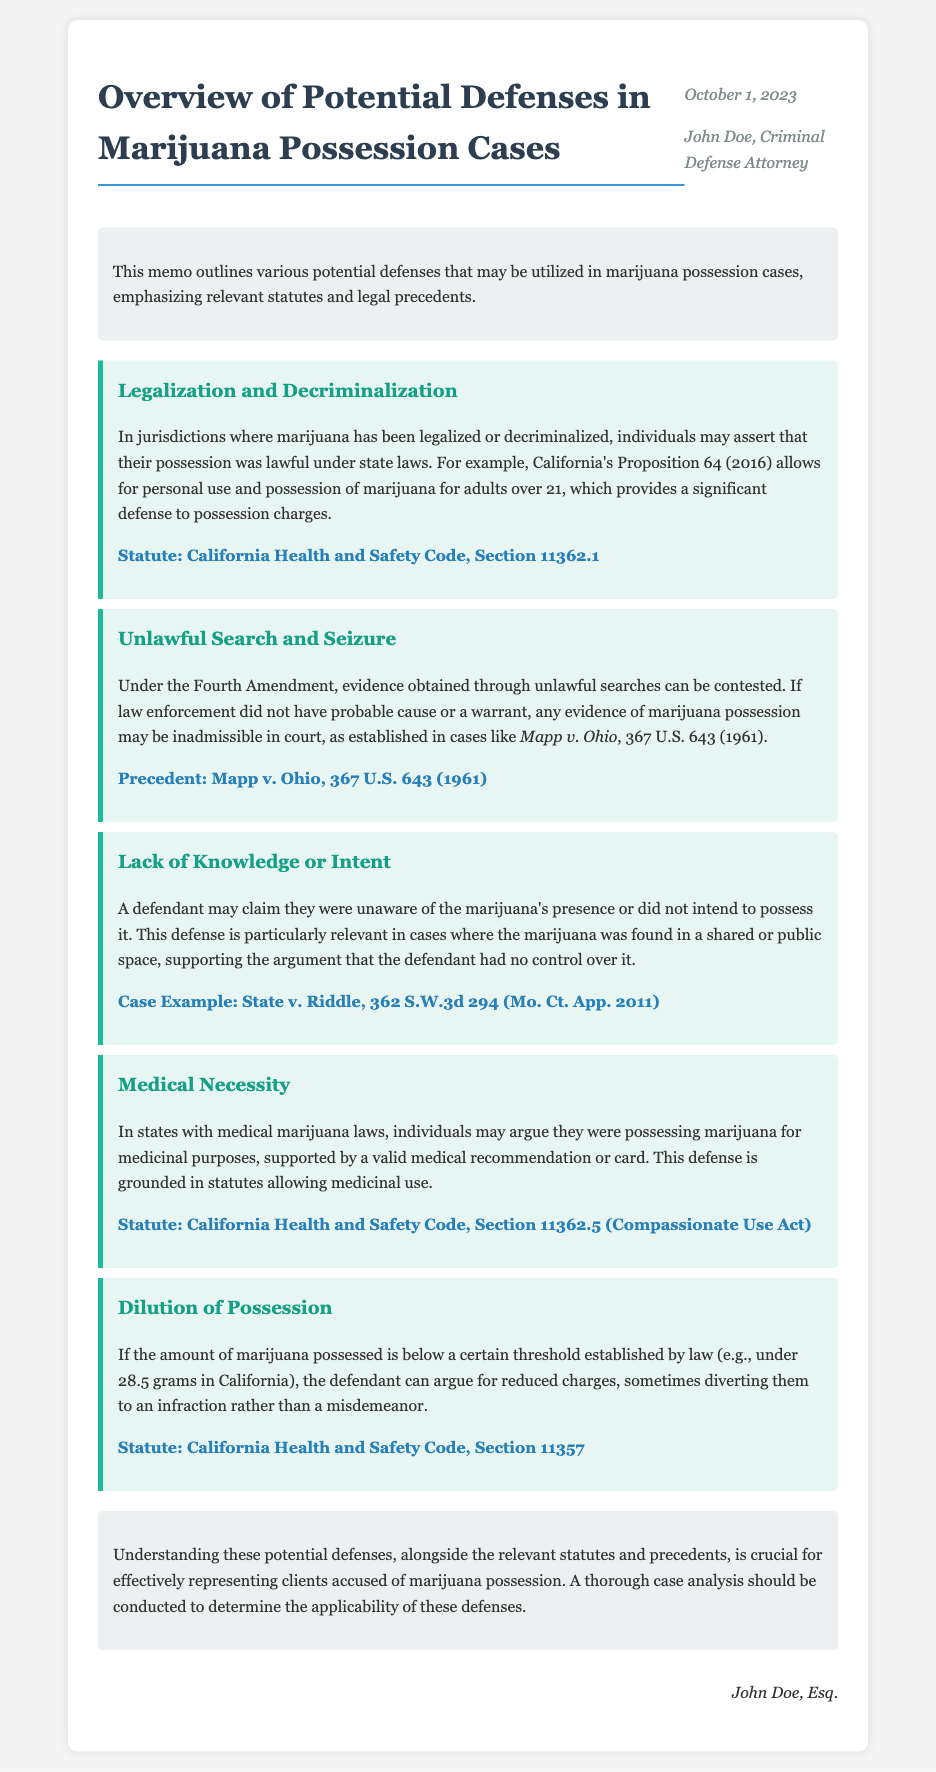What is the title of the memo? The title is found at the top of the document and states the subject of the memo.
Answer: Overview of Potential Defenses in Marijuana Possession Cases Who authored the memo? The author's name is presented in the header section of the memo.
Answer: John Doe, Criminal Defense Attorney What is the date of the memo? The date is given next to the author's name in the header.
Answer: October 1, 2023 What statute is referenced for legalization and decriminalization defenses? This information is provided under the relevant defense section discussing legality in jurisdictions.
Answer: California Health and Safety Code, Section 11362.1 What precedent is cited regarding unlawful search and seizure? The document mentions a landmark case in relation to this defense strategy.
Answer: Mapp v. Ohio, 367 U.S. 643 (1961) What is the defense related to the presence of marijuana in a shared space? The memo discusses this specific defense under lack of knowledge or intent.
Answer: Lack of Knowledge or Intent What medical law is mentioned in relation to possessing marijuana? This detail is included to support the medical necessity defense outlined in the memo.
Answer: California Health and Safety Code, Section 11362.5 (Compassionate Use Act) What is the threshold amount for dilution of possession mentioned? This figure indicates the amount of marijuana that can lead to reduced charges.
Answer: Under 28.5 grams Which case example is provided for lack of knowledge or intent defense? The memo provides an example case to illustrate this defense.
Answer: State v. Riddle, 362 S.W.3d 294 (Mo. Ct. App. 2011) What is the main conclusion highlighted in the memo? The conclusion summarizes the importance of understanding defenses in marijuana possession cases.
Answer: Understanding these potential defenses is crucial for effectively representing clients accused of marijuana possession 